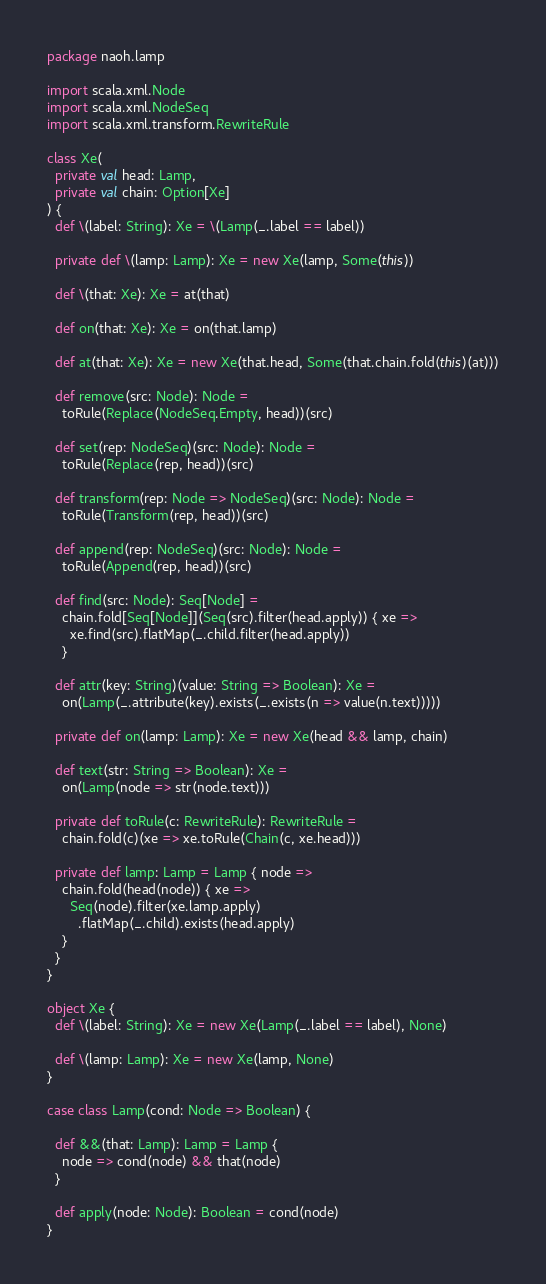<code> <loc_0><loc_0><loc_500><loc_500><_Scala_>package naoh.lamp

import scala.xml.Node
import scala.xml.NodeSeq
import scala.xml.transform.RewriteRule

class Xe(
  private val head: Lamp,
  private val chain: Option[Xe]
) {
  def \(label: String): Xe = \(Lamp(_.label == label))

  private def \(lamp: Lamp): Xe = new Xe(lamp, Some(this))

  def \(that: Xe): Xe = at(that)

  def on(that: Xe): Xe = on(that.lamp)

  def at(that: Xe): Xe = new Xe(that.head, Some(that.chain.fold(this)(at)))

  def remove(src: Node): Node =
    toRule(Replace(NodeSeq.Empty, head))(src)

  def set(rep: NodeSeq)(src: Node): Node =
    toRule(Replace(rep, head))(src)

  def transform(rep: Node => NodeSeq)(src: Node): Node =
    toRule(Transform(rep, head))(src)

  def append(rep: NodeSeq)(src: Node): Node =
    toRule(Append(rep, head))(src)

  def find(src: Node): Seq[Node] =
    chain.fold[Seq[Node]](Seq(src).filter(head.apply)) { xe =>
      xe.find(src).flatMap(_.child.filter(head.apply))
    }

  def attr(key: String)(value: String => Boolean): Xe =
    on(Lamp(_.attribute(key).exists(_.exists(n => value(n.text)))))

  private def on(lamp: Lamp): Xe = new Xe(head && lamp, chain)

  def text(str: String => Boolean): Xe =
    on(Lamp(node => str(node.text)))

  private def toRule(c: RewriteRule): RewriteRule =
    chain.fold(c)(xe => xe.toRule(Chain(c, xe.head)))

  private def lamp: Lamp = Lamp { node =>
    chain.fold(head(node)) { xe =>
      Seq(node).filter(xe.lamp.apply)
        .flatMap(_.child).exists(head.apply)
    }
  }
}

object Xe {
  def \(label: String): Xe = new Xe(Lamp(_.label == label), None)

  def \(lamp: Lamp): Xe = new Xe(lamp, None)
}

case class Lamp(cond: Node => Boolean) {

  def &&(that: Lamp): Lamp = Lamp {
    node => cond(node) && that(node)
  }

  def apply(node: Node): Boolean = cond(node)
}
</code> 